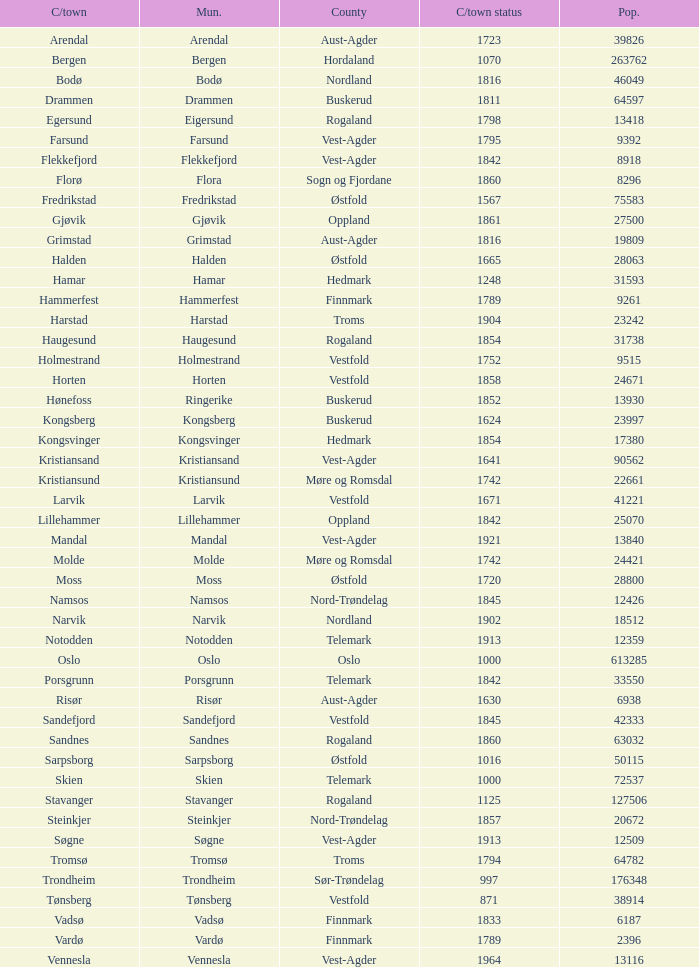What is the total population in the city/town of Arendal? 1.0. 